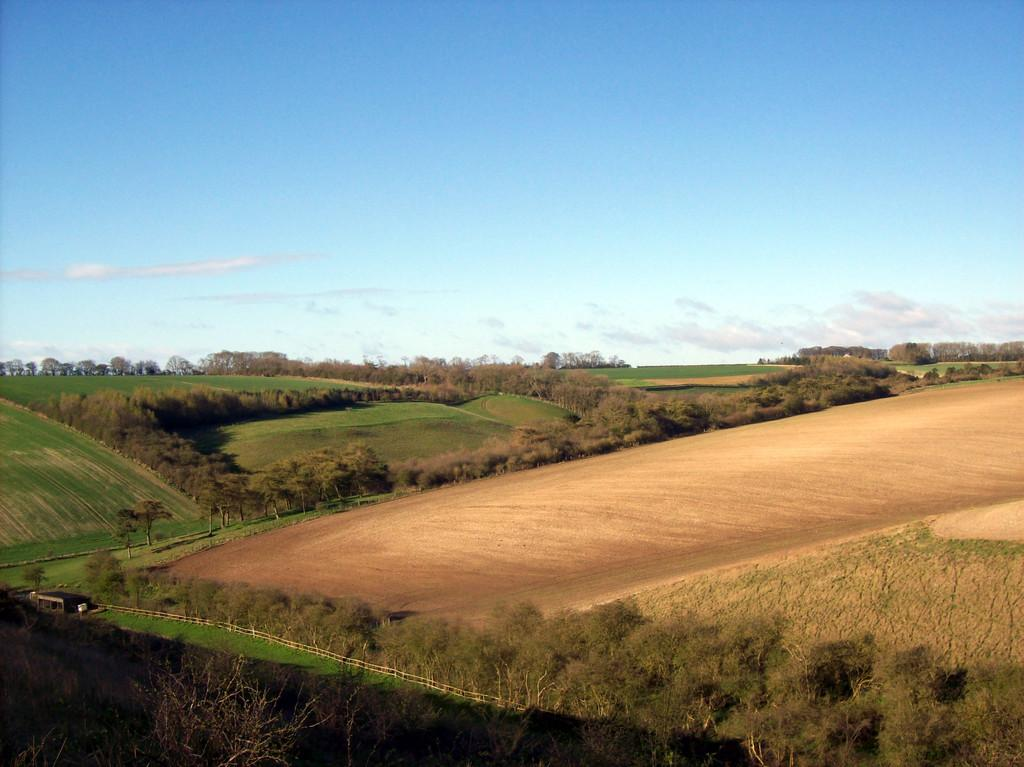What is the primary feature of the image? The primary feature of the image is the presence of many fields. Can you describe the surroundings of the fields? There are a lot of trees around the fields in the image. What type of arch can be seen in the image? There is no arch present in the image; it features fields and trees. Is there a letter addressed to someone in the image? There is no letter present in the image; it only shows fields and trees. 